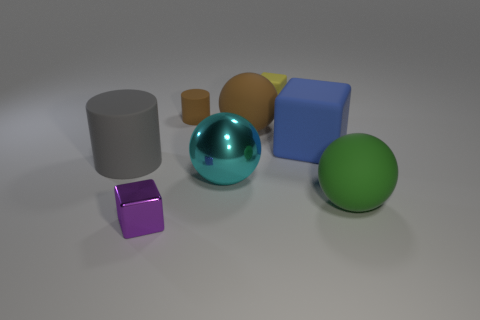Can you describe the composition and texture of the objects in the image? Certainly! The image shows a variety of geometric shapes with different compositions and textures. There's a large metallic sphere with a reflective surface, a matte cylinder, a small rubber cube with a matte finish, a smaller sphere with a velvety texture, and other objects that appear smooth and likely made of plastic. These objects are arranged on a flat surface, creating a diverse and interesting collection of forms and materials. 